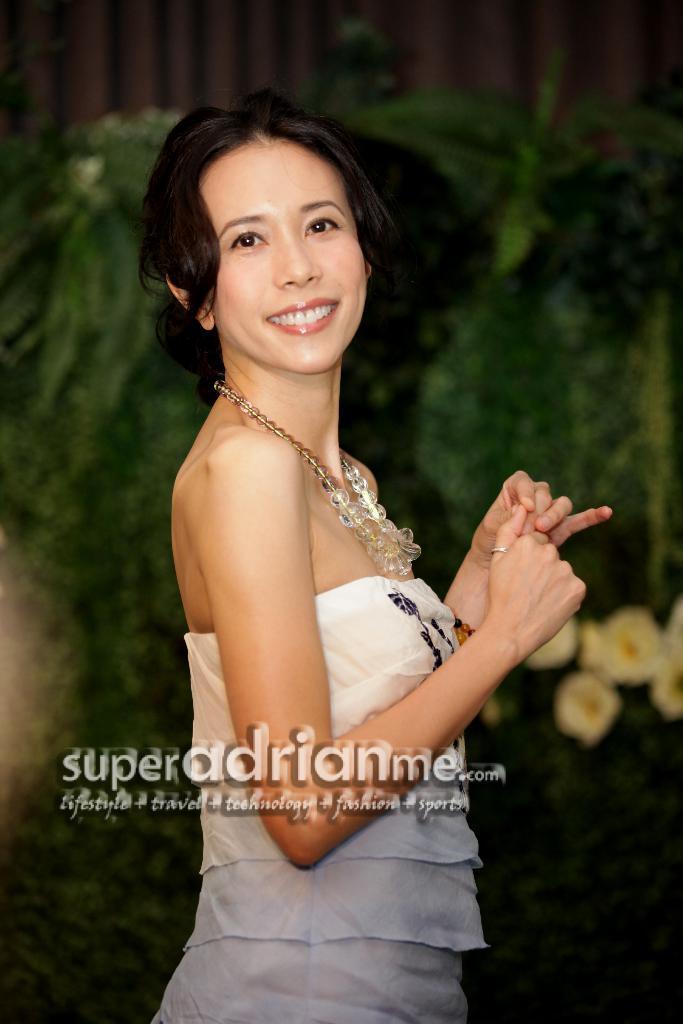Can you describe this image briefly? In the foreground of this picture, there is a woman in white dress and having smile on her face. In the background, there are flowers to the plants and a railing. 